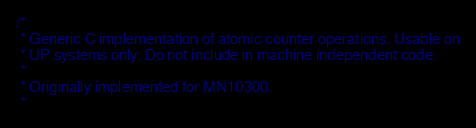<code> <loc_0><loc_0><loc_500><loc_500><_C_>/*
 * Generic C implementation of atomic counter operations. Usable on
 * UP systems only. Do not include in machine independent code.
 *
 * Originally implemented for MN10300.
 *</code> 